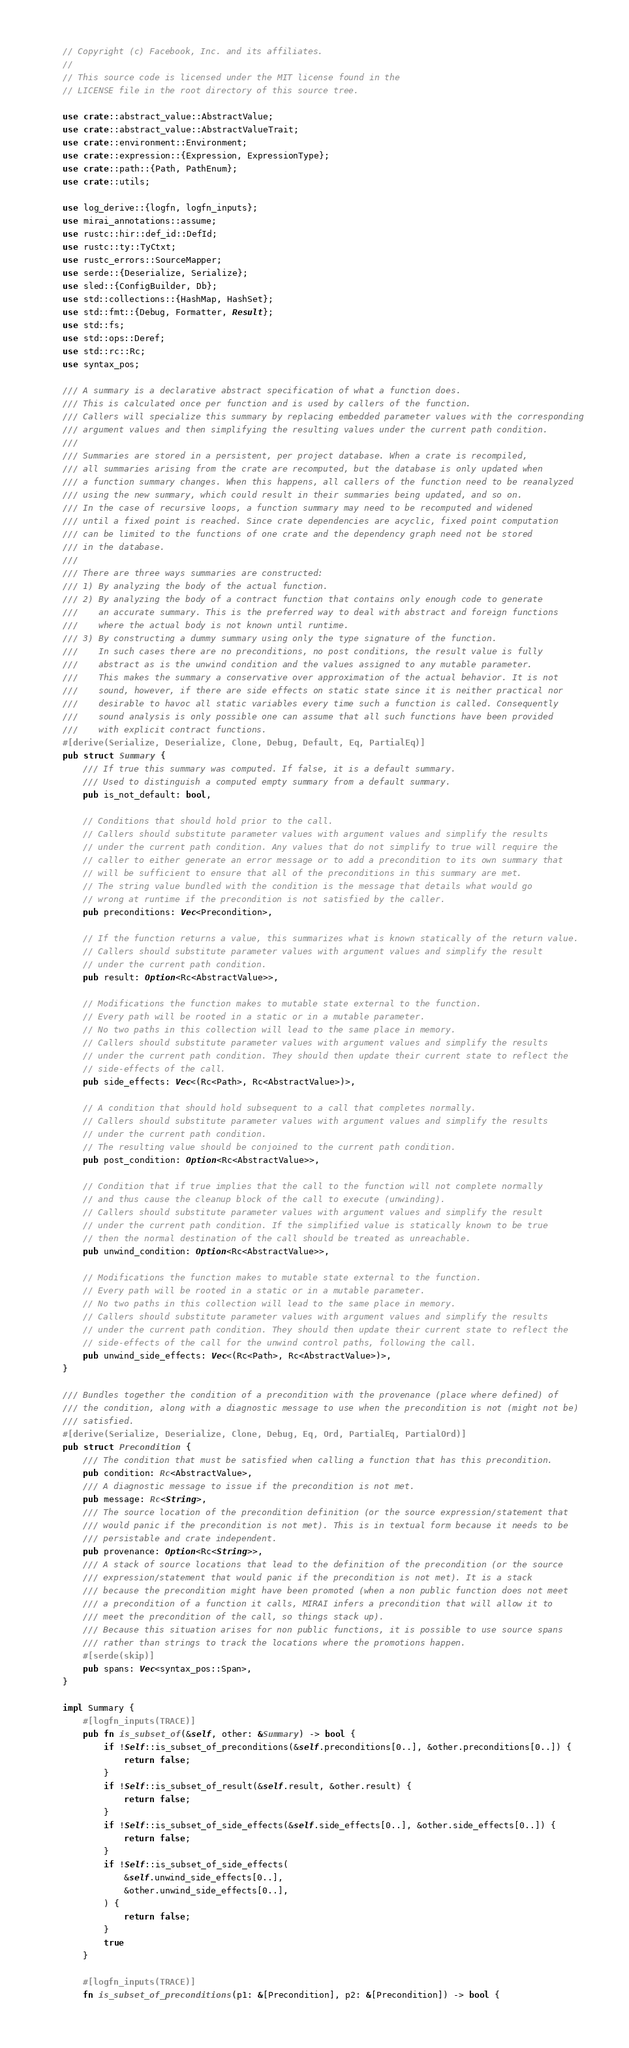<code> <loc_0><loc_0><loc_500><loc_500><_Rust_>// Copyright (c) Facebook, Inc. and its affiliates.
//
// This source code is licensed under the MIT license found in the
// LICENSE file in the root directory of this source tree.

use crate::abstract_value::AbstractValue;
use crate::abstract_value::AbstractValueTrait;
use crate::environment::Environment;
use crate::expression::{Expression, ExpressionType};
use crate::path::{Path, PathEnum};
use crate::utils;

use log_derive::{logfn, logfn_inputs};
use mirai_annotations::assume;
use rustc::hir::def_id::DefId;
use rustc::ty::TyCtxt;
use rustc_errors::SourceMapper;
use serde::{Deserialize, Serialize};
use sled::{ConfigBuilder, Db};
use std::collections::{HashMap, HashSet};
use std::fmt::{Debug, Formatter, Result};
use std::fs;
use std::ops::Deref;
use std::rc::Rc;
use syntax_pos;

/// A summary is a declarative abstract specification of what a function does.
/// This is calculated once per function and is used by callers of the function.
/// Callers will specialize this summary by replacing embedded parameter values with the corresponding
/// argument values and then simplifying the resulting values under the current path condition.
///
/// Summaries are stored in a persistent, per project database. When a crate is recompiled,
/// all summaries arising from the crate are recomputed, but the database is only updated when
/// a function summary changes. When this happens, all callers of the function need to be reanalyzed
/// using the new summary, which could result in their summaries being updated, and so on.
/// In the case of recursive loops, a function summary may need to be recomputed and widened
/// until a fixed point is reached. Since crate dependencies are acyclic, fixed point computation
/// can be limited to the functions of one crate and the dependency graph need not be stored
/// in the database.
///
/// There are three ways summaries are constructed:
/// 1) By analyzing the body of the actual function.
/// 2) By analyzing the body of a contract function that contains only enough code to generate
///    an accurate summary. This is the preferred way to deal with abstract and foreign functions
///    where the actual body is not known until runtime.
/// 3) By constructing a dummy summary using only the type signature of the function.
///    In such cases there are no preconditions, no post conditions, the result value is fully
///    abstract as is the unwind condition and the values assigned to any mutable parameter.
///    This makes the summary a conservative over approximation of the actual behavior. It is not
///    sound, however, if there are side effects on static state since it is neither practical nor
///    desirable to havoc all static variables every time such a function is called. Consequently
///    sound analysis is only possible one can assume that all such functions have been provided
///    with explicit contract functions.
#[derive(Serialize, Deserialize, Clone, Debug, Default, Eq, PartialEq)]
pub struct Summary {
    /// If true this summary was computed. If false, it is a default summary.
    /// Used to distinguish a computed empty summary from a default summary.
    pub is_not_default: bool,

    // Conditions that should hold prior to the call.
    // Callers should substitute parameter values with argument values and simplify the results
    // under the current path condition. Any values that do not simplify to true will require the
    // caller to either generate an error message or to add a precondition to its own summary that
    // will be sufficient to ensure that all of the preconditions in this summary are met.
    // The string value bundled with the condition is the message that details what would go
    // wrong at runtime if the precondition is not satisfied by the caller.
    pub preconditions: Vec<Precondition>,

    // If the function returns a value, this summarizes what is known statically of the return value.
    // Callers should substitute parameter values with argument values and simplify the result
    // under the current path condition.
    pub result: Option<Rc<AbstractValue>>,

    // Modifications the function makes to mutable state external to the function.
    // Every path will be rooted in a static or in a mutable parameter.
    // No two paths in this collection will lead to the same place in memory.
    // Callers should substitute parameter values with argument values and simplify the results
    // under the current path condition. They should then update their current state to reflect the
    // side-effects of the call.
    pub side_effects: Vec<(Rc<Path>, Rc<AbstractValue>)>,

    // A condition that should hold subsequent to a call that completes normally.
    // Callers should substitute parameter values with argument values and simplify the results
    // under the current path condition.
    // The resulting value should be conjoined to the current path condition.
    pub post_condition: Option<Rc<AbstractValue>>,

    // Condition that if true implies that the call to the function will not complete normally
    // and thus cause the cleanup block of the call to execute (unwinding).
    // Callers should substitute parameter values with argument values and simplify the result
    // under the current path condition. If the simplified value is statically known to be true
    // then the normal destination of the call should be treated as unreachable.
    pub unwind_condition: Option<Rc<AbstractValue>>,

    // Modifications the function makes to mutable state external to the function.
    // Every path will be rooted in a static or in a mutable parameter.
    // No two paths in this collection will lead to the same place in memory.
    // Callers should substitute parameter values with argument values and simplify the results
    // under the current path condition. They should then update their current state to reflect the
    // side-effects of the call for the unwind control paths, following the call.
    pub unwind_side_effects: Vec<(Rc<Path>, Rc<AbstractValue>)>,
}

/// Bundles together the condition of a precondition with the provenance (place where defined) of
/// the condition, along with a diagnostic message to use when the precondition is not (might not be)
/// satisfied.
#[derive(Serialize, Deserialize, Clone, Debug, Eq, Ord, PartialEq, PartialOrd)]
pub struct Precondition {
    /// The condition that must be satisfied when calling a function that has this precondition.
    pub condition: Rc<AbstractValue>,
    /// A diagnostic message to issue if the precondition is not met.
    pub message: Rc<String>,
    /// The source location of the precondition definition (or the source expression/statement that
    /// would panic if the precondition is not met). This is in textual form because it needs to be
    /// persistable and crate independent.
    pub provenance: Option<Rc<String>>,
    /// A stack of source locations that lead to the definition of the precondition (or the source
    /// expression/statement that would panic if the precondition is not met). It is a stack
    /// because the precondition might have been promoted (when a non public function does not meet
    /// a precondition of a function it calls, MIRAI infers a precondition that will allow it to
    /// meet the precondition of the call, so things stack up).
    /// Because this situation arises for non public functions, it is possible to use source spans
    /// rather than strings to track the locations where the promotions happen.
    #[serde(skip)]
    pub spans: Vec<syntax_pos::Span>,
}

impl Summary {
    #[logfn_inputs(TRACE)]
    pub fn is_subset_of(&self, other: &Summary) -> bool {
        if !Self::is_subset_of_preconditions(&self.preconditions[0..], &other.preconditions[0..]) {
            return false;
        }
        if !Self::is_subset_of_result(&self.result, &other.result) {
            return false;
        }
        if !Self::is_subset_of_side_effects(&self.side_effects[0..], &other.side_effects[0..]) {
            return false;
        }
        if !Self::is_subset_of_side_effects(
            &self.unwind_side_effects[0..],
            &other.unwind_side_effects[0..],
        ) {
            return false;
        }
        true
    }

    #[logfn_inputs(TRACE)]
    fn is_subset_of_preconditions(p1: &[Precondition], p2: &[Precondition]) -> bool {</code> 